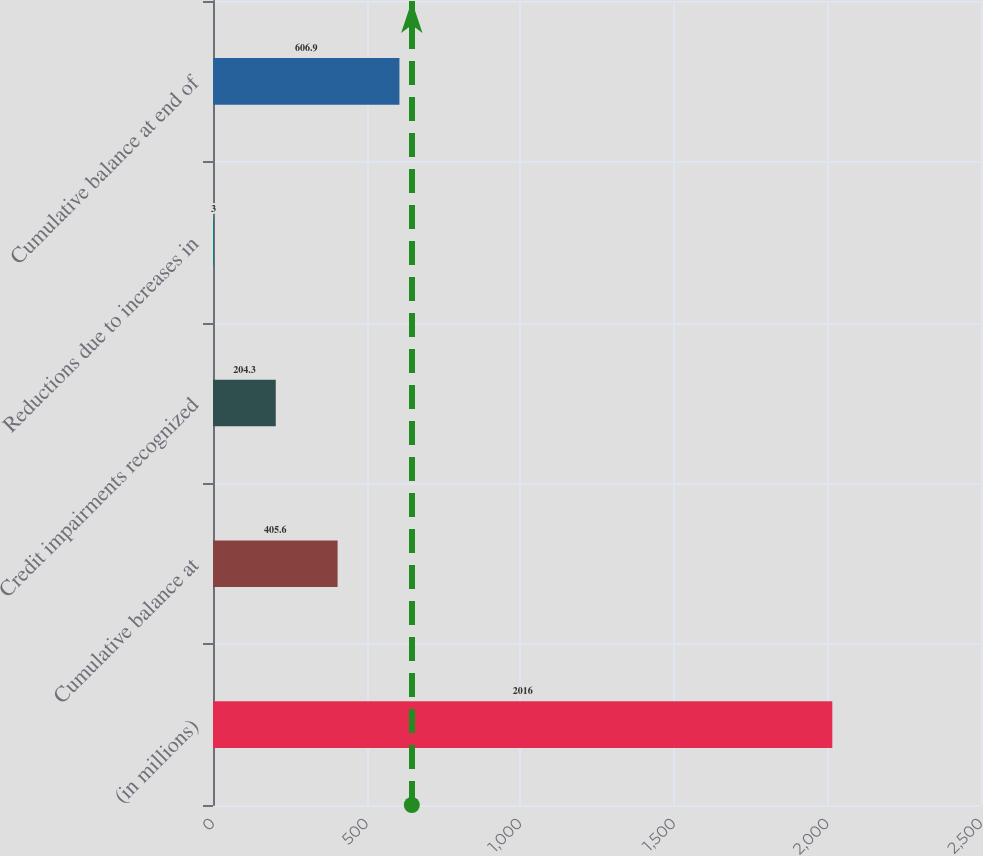Convert chart. <chart><loc_0><loc_0><loc_500><loc_500><bar_chart><fcel>(in millions)<fcel>Cumulative balance at<fcel>Credit impairments recognized<fcel>Reductions due to increases in<fcel>Cumulative balance at end of<nl><fcel>2016<fcel>405.6<fcel>204.3<fcel>3<fcel>606.9<nl></chart> 